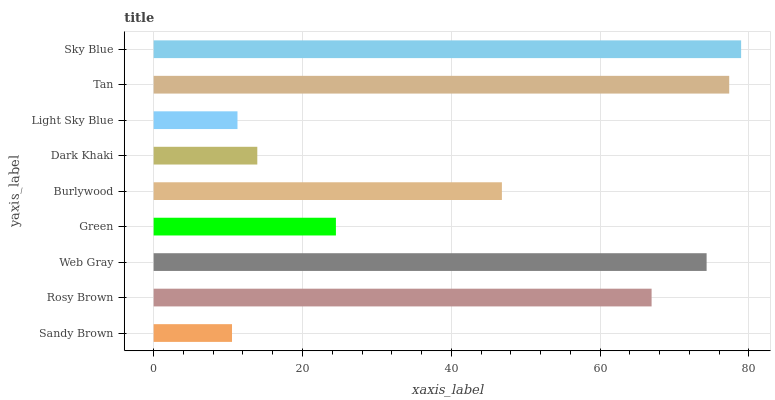Is Sandy Brown the minimum?
Answer yes or no. Yes. Is Sky Blue the maximum?
Answer yes or no. Yes. Is Rosy Brown the minimum?
Answer yes or no. No. Is Rosy Brown the maximum?
Answer yes or no. No. Is Rosy Brown greater than Sandy Brown?
Answer yes or no. Yes. Is Sandy Brown less than Rosy Brown?
Answer yes or no. Yes. Is Sandy Brown greater than Rosy Brown?
Answer yes or no. No. Is Rosy Brown less than Sandy Brown?
Answer yes or no. No. Is Burlywood the high median?
Answer yes or no. Yes. Is Burlywood the low median?
Answer yes or no. Yes. Is Rosy Brown the high median?
Answer yes or no. No. Is Tan the low median?
Answer yes or no. No. 